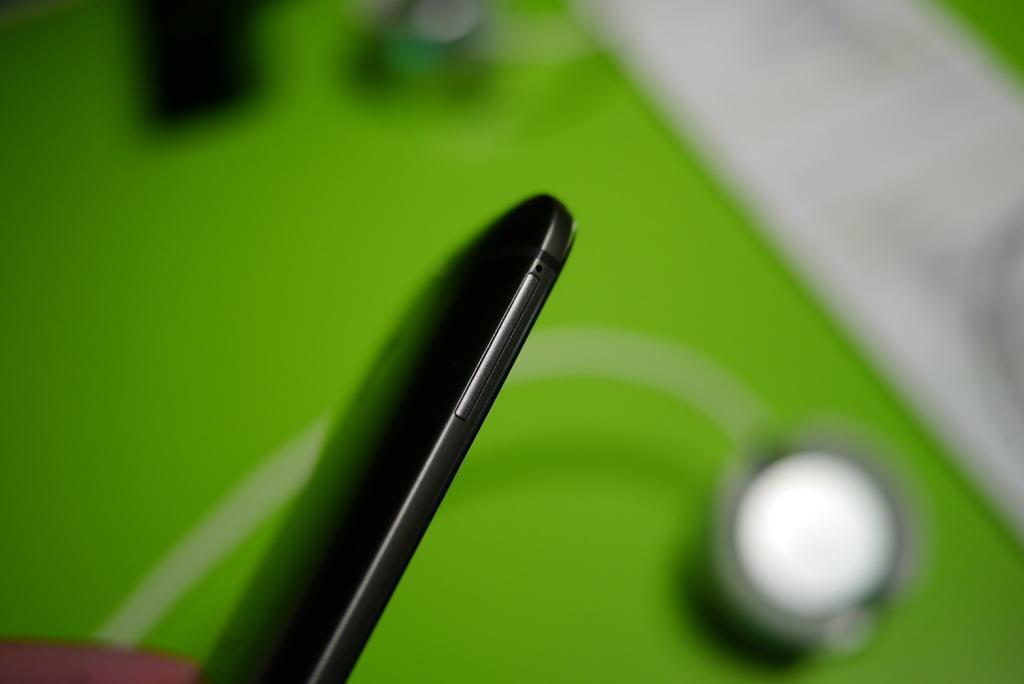Please provide a concise description of this image. In this image we can see a mobile phone. 